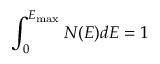<formula> <loc_0><loc_0><loc_500><loc_500>\int _ { 0 } ^ { E _ { \max } } N ( E ) d E = 1</formula> 